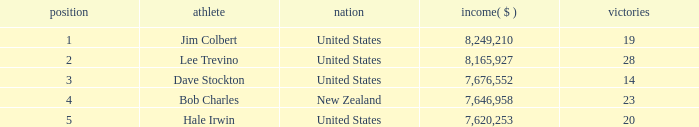How many players named bob charles with earnings over $7,646,958? 0.0. 